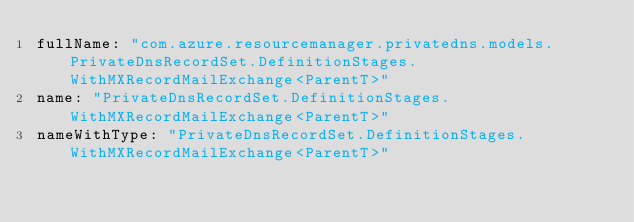Convert code to text. <code><loc_0><loc_0><loc_500><loc_500><_YAML_>fullName: "com.azure.resourcemanager.privatedns.models.PrivateDnsRecordSet.DefinitionStages.WithMXRecordMailExchange<ParentT>"
name: "PrivateDnsRecordSet.DefinitionStages.WithMXRecordMailExchange<ParentT>"
nameWithType: "PrivateDnsRecordSet.DefinitionStages.WithMXRecordMailExchange<ParentT>"</code> 